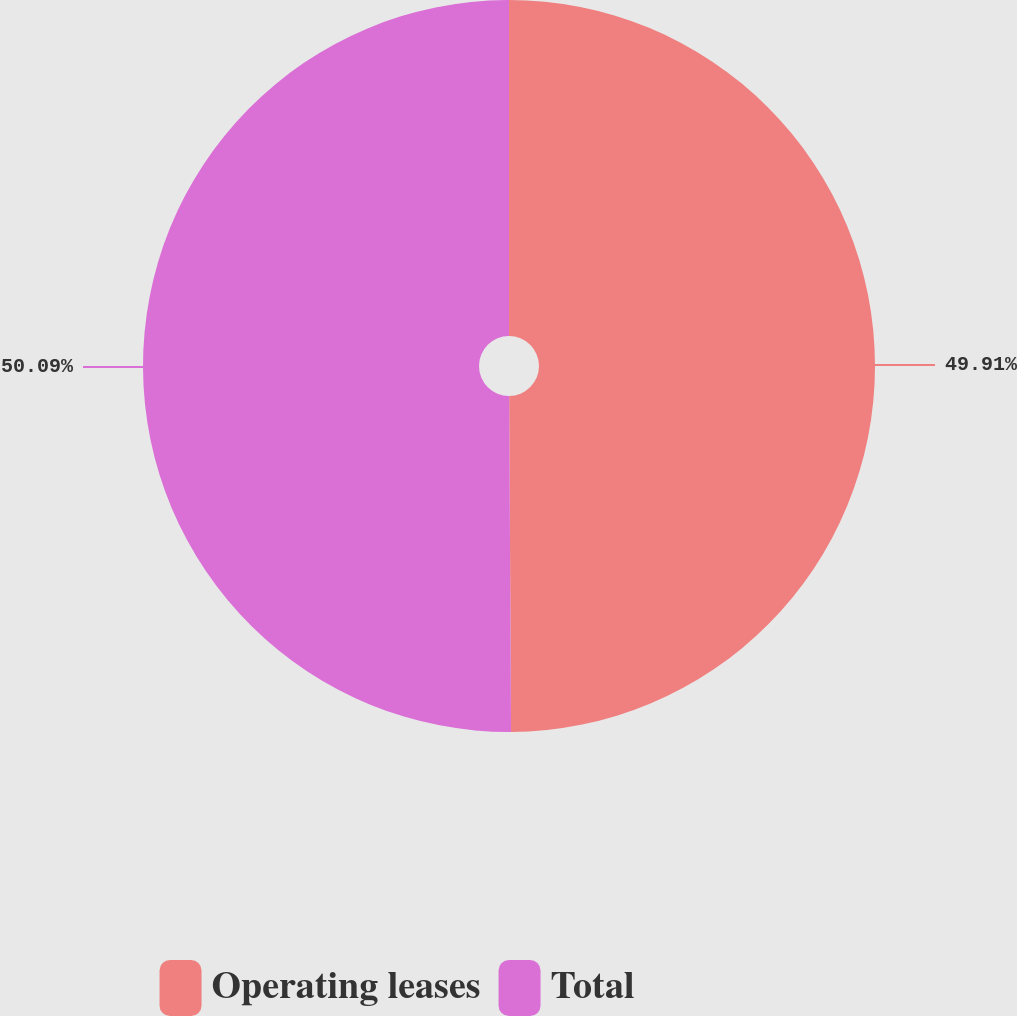<chart> <loc_0><loc_0><loc_500><loc_500><pie_chart><fcel>Operating leases<fcel>Total<nl><fcel>49.91%<fcel>50.09%<nl></chart> 